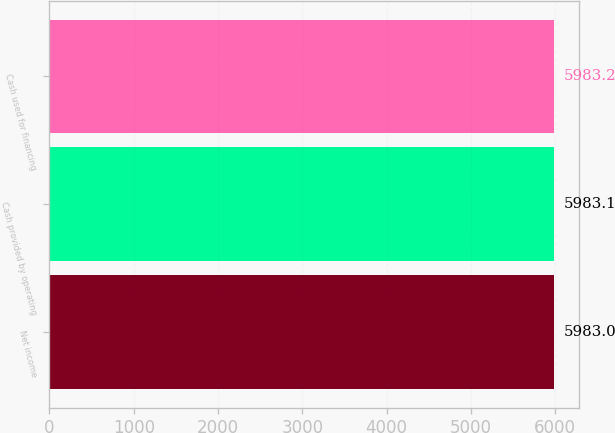Convert chart to OTSL. <chart><loc_0><loc_0><loc_500><loc_500><bar_chart><fcel>Net income<fcel>Cash provided by operating<fcel>Cash used for financing<nl><fcel>5983<fcel>5983.1<fcel>5983.2<nl></chart> 